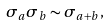Convert formula to latex. <formula><loc_0><loc_0><loc_500><loc_500>\sigma _ { a } \sigma _ { b } \sim \sigma _ { a + b } ,</formula> 